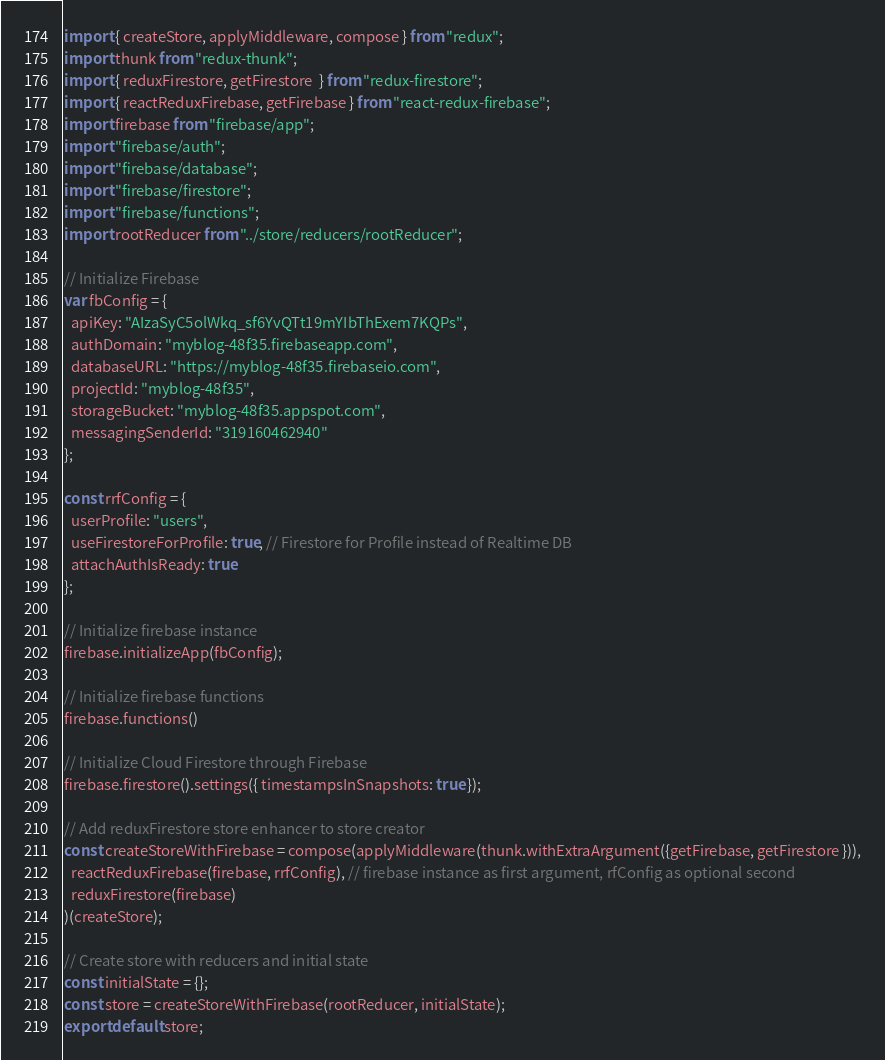<code> <loc_0><loc_0><loc_500><loc_500><_JavaScript_>import { createStore, applyMiddleware, compose } from "redux";
import thunk from "redux-thunk";
import { reduxFirestore, getFirestore  } from "redux-firestore";
import { reactReduxFirebase, getFirebase } from "react-redux-firebase";
import firebase from "firebase/app";
import "firebase/auth";
import "firebase/database";
import "firebase/firestore";
import "firebase/functions";
import rootReducer from "../store/reducers/rootReducer";

// Initialize Firebase
var fbConfig = {
  apiKey: "AIzaSyC5olWkq_sf6YvQTt19mYIbThExem7KQPs",
  authDomain: "myblog-48f35.firebaseapp.com",
  databaseURL: "https://myblog-48f35.firebaseio.com",
  projectId: "myblog-48f35",
  storageBucket: "myblog-48f35.appspot.com",
  messagingSenderId: "319160462940"
};

const rrfConfig = {
  userProfile: "users",
  useFirestoreForProfile: true, // Firestore for Profile instead of Realtime DB
  attachAuthIsReady: true
};

// Initialize firebase instance
firebase.initializeApp(fbConfig);

// Initialize firebase functions
firebase.functions()

// Initialize Cloud Firestore through Firebase
firebase.firestore().settings({ timestampsInSnapshots: true });

// Add reduxFirestore store enhancer to store creator
const createStoreWithFirebase = compose(applyMiddleware(thunk.withExtraArgument({getFirebase, getFirestore })),
  reactReduxFirebase(firebase, rrfConfig), // firebase instance as first argument, rfConfig as optional second
  reduxFirestore(firebase)
)(createStore);

// Create store with reducers and initial state
const initialState = {};
const store = createStoreWithFirebase(rootReducer, initialState);
export default store;
</code> 